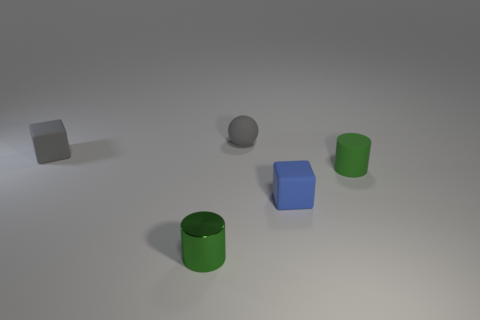What number of other objects are the same size as the blue cube?
Your response must be concise. 4. What shape is the other object that is the same color as the metal thing?
Provide a short and direct response. Cylinder. What number of blue rubber objects are the same shape as the tiny green shiny object?
Keep it short and to the point. 0. There is a gray block that is made of the same material as the blue object; what size is it?
Provide a short and direct response. Small. Is the number of gray rubber cubes behind the matte sphere the same as the number of small matte spheres?
Ensure brevity in your answer.  No. Do the tiny ball and the small rubber cylinder have the same color?
Offer a very short reply. No. Is the shape of the gray object to the left of the sphere the same as the small object in front of the blue matte cube?
Offer a terse response. No. There is another small green object that is the same shape as the green rubber thing; what is it made of?
Provide a short and direct response. Metal. There is a thing that is to the left of the blue rubber thing and to the right of the small shiny cylinder; what is its color?
Provide a short and direct response. Gray. Are there any small gray spheres that are to the left of the tiny gray thing that is behind the tiny gray object in front of the tiny matte ball?
Give a very brief answer. No. 